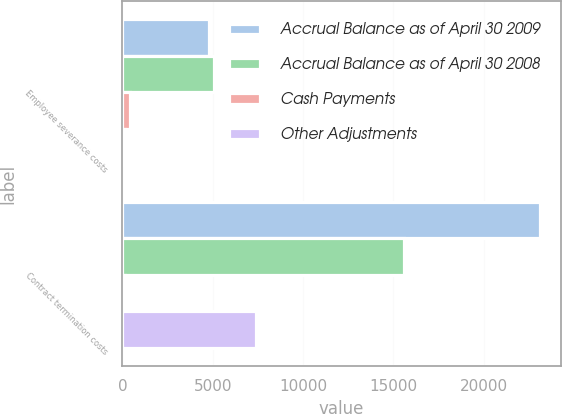Convert chart to OTSL. <chart><loc_0><loc_0><loc_500><loc_500><stacked_bar_chart><ecel><fcel>Employee severance costs<fcel>Contract termination costs<nl><fcel>Accrual Balance as of April 30 2009<fcel>4807<fcel>23113<nl><fcel>Accrual Balance as of April 30 2008<fcel>5068<fcel>15594<nl><fcel>Cash Payments<fcel>408<fcel>133<nl><fcel>Other Adjustments<fcel>147<fcel>7386<nl></chart> 